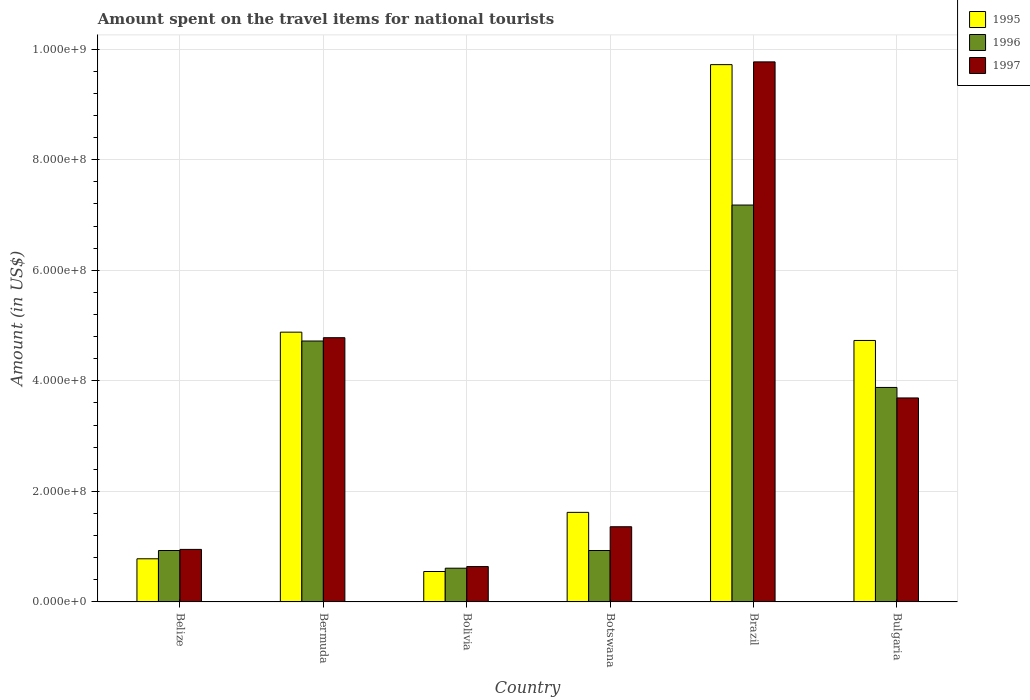How many different coloured bars are there?
Provide a succinct answer. 3. How many groups of bars are there?
Offer a very short reply. 6. How many bars are there on the 2nd tick from the left?
Give a very brief answer. 3. What is the label of the 2nd group of bars from the left?
Your answer should be very brief. Bermuda. In how many cases, is the number of bars for a given country not equal to the number of legend labels?
Offer a very short reply. 0. What is the amount spent on the travel items for national tourists in 1995 in Belize?
Your answer should be very brief. 7.80e+07. Across all countries, what is the maximum amount spent on the travel items for national tourists in 1997?
Make the answer very short. 9.77e+08. Across all countries, what is the minimum amount spent on the travel items for national tourists in 1995?
Keep it short and to the point. 5.50e+07. In which country was the amount spent on the travel items for national tourists in 1995 maximum?
Provide a succinct answer. Brazil. In which country was the amount spent on the travel items for national tourists in 1996 minimum?
Give a very brief answer. Bolivia. What is the total amount spent on the travel items for national tourists in 1995 in the graph?
Ensure brevity in your answer.  2.23e+09. What is the difference between the amount spent on the travel items for national tourists in 1997 in Belize and that in Bermuda?
Offer a very short reply. -3.83e+08. What is the difference between the amount spent on the travel items for national tourists in 1997 in Botswana and the amount spent on the travel items for national tourists in 1995 in Bolivia?
Ensure brevity in your answer.  8.10e+07. What is the average amount spent on the travel items for national tourists in 1997 per country?
Provide a short and direct response. 3.53e+08. What is the difference between the amount spent on the travel items for national tourists of/in 1995 and amount spent on the travel items for national tourists of/in 1996 in Bulgaria?
Your answer should be very brief. 8.50e+07. What is the ratio of the amount spent on the travel items for national tourists in 1995 in Bermuda to that in Botswana?
Provide a short and direct response. 3.01. Is the difference between the amount spent on the travel items for national tourists in 1995 in Brazil and Bulgaria greater than the difference between the amount spent on the travel items for national tourists in 1996 in Brazil and Bulgaria?
Give a very brief answer. Yes. What is the difference between the highest and the second highest amount spent on the travel items for national tourists in 1997?
Offer a very short reply. 6.08e+08. What is the difference between the highest and the lowest amount spent on the travel items for national tourists in 1995?
Make the answer very short. 9.17e+08. In how many countries, is the amount spent on the travel items for national tourists in 1996 greater than the average amount spent on the travel items for national tourists in 1996 taken over all countries?
Ensure brevity in your answer.  3. Is the sum of the amount spent on the travel items for national tourists in 1996 in Belize and Bermuda greater than the maximum amount spent on the travel items for national tourists in 1997 across all countries?
Your answer should be compact. No. What does the 2nd bar from the left in Brazil represents?
Provide a short and direct response. 1996. What does the 1st bar from the right in Bulgaria represents?
Offer a very short reply. 1997. Is it the case that in every country, the sum of the amount spent on the travel items for national tourists in 1996 and amount spent on the travel items for national tourists in 1997 is greater than the amount spent on the travel items for national tourists in 1995?
Make the answer very short. Yes. How many bars are there?
Offer a very short reply. 18. How many countries are there in the graph?
Your answer should be very brief. 6. What is the difference between two consecutive major ticks on the Y-axis?
Keep it short and to the point. 2.00e+08. Are the values on the major ticks of Y-axis written in scientific E-notation?
Offer a terse response. Yes. Does the graph contain any zero values?
Offer a terse response. No. Where does the legend appear in the graph?
Offer a very short reply. Top right. How many legend labels are there?
Your answer should be compact. 3. How are the legend labels stacked?
Provide a short and direct response. Vertical. What is the title of the graph?
Provide a succinct answer. Amount spent on the travel items for national tourists. Does "1993" appear as one of the legend labels in the graph?
Offer a very short reply. No. What is the label or title of the X-axis?
Ensure brevity in your answer.  Country. What is the label or title of the Y-axis?
Make the answer very short. Amount (in US$). What is the Amount (in US$) of 1995 in Belize?
Your answer should be compact. 7.80e+07. What is the Amount (in US$) of 1996 in Belize?
Keep it short and to the point. 9.30e+07. What is the Amount (in US$) of 1997 in Belize?
Provide a succinct answer. 9.50e+07. What is the Amount (in US$) in 1995 in Bermuda?
Your answer should be very brief. 4.88e+08. What is the Amount (in US$) of 1996 in Bermuda?
Your answer should be compact. 4.72e+08. What is the Amount (in US$) in 1997 in Bermuda?
Give a very brief answer. 4.78e+08. What is the Amount (in US$) of 1995 in Bolivia?
Your answer should be compact. 5.50e+07. What is the Amount (in US$) in 1996 in Bolivia?
Offer a very short reply. 6.10e+07. What is the Amount (in US$) in 1997 in Bolivia?
Provide a succinct answer. 6.40e+07. What is the Amount (in US$) of 1995 in Botswana?
Provide a short and direct response. 1.62e+08. What is the Amount (in US$) of 1996 in Botswana?
Provide a succinct answer. 9.30e+07. What is the Amount (in US$) in 1997 in Botswana?
Your answer should be very brief. 1.36e+08. What is the Amount (in US$) of 1995 in Brazil?
Ensure brevity in your answer.  9.72e+08. What is the Amount (in US$) in 1996 in Brazil?
Ensure brevity in your answer.  7.18e+08. What is the Amount (in US$) in 1997 in Brazil?
Offer a very short reply. 9.77e+08. What is the Amount (in US$) in 1995 in Bulgaria?
Ensure brevity in your answer.  4.73e+08. What is the Amount (in US$) in 1996 in Bulgaria?
Your answer should be compact. 3.88e+08. What is the Amount (in US$) of 1997 in Bulgaria?
Offer a terse response. 3.69e+08. Across all countries, what is the maximum Amount (in US$) in 1995?
Ensure brevity in your answer.  9.72e+08. Across all countries, what is the maximum Amount (in US$) of 1996?
Your answer should be very brief. 7.18e+08. Across all countries, what is the maximum Amount (in US$) in 1997?
Ensure brevity in your answer.  9.77e+08. Across all countries, what is the minimum Amount (in US$) of 1995?
Your answer should be compact. 5.50e+07. Across all countries, what is the minimum Amount (in US$) in 1996?
Offer a very short reply. 6.10e+07. Across all countries, what is the minimum Amount (in US$) of 1997?
Make the answer very short. 6.40e+07. What is the total Amount (in US$) of 1995 in the graph?
Your response must be concise. 2.23e+09. What is the total Amount (in US$) in 1996 in the graph?
Your answer should be very brief. 1.82e+09. What is the total Amount (in US$) in 1997 in the graph?
Keep it short and to the point. 2.12e+09. What is the difference between the Amount (in US$) of 1995 in Belize and that in Bermuda?
Keep it short and to the point. -4.10e+08. What is the difference between the Amount (in US$) of 1996 in Belize and that in Bermuda?
Offer a very short reply. -3.79e+08. What is the difference between the Amount (in US$) in 1997 in Belize and that in Bermuda?
Offer a terse response. -3.83e+08. What is the difference between the Amount (in US$) of 1995 in Belize and that in Bolivia?
Offer a very short reply. 2.30e+07. What is the difference between the Amount (in US$) of 1996 in Belize and that in Bolivia?
Provide a succinct answer. 3.20e+07. What is the difference between the Amount (in US$) of 1997 in Belize and that in Bolivia?
Your response must be concise. 3.10e+07. What is the difference between the Amount (in US$) of 1995 in Belize and that in Botswana?
Your answer should be very brief. -8.40e+07. What is the difference between the Amount (in US$) in 1997 in Belize and that in Botswana?
Offer a very short reply. -4.10e+07. What is the difference between the Amount (in US$) of 1995 in Belize and that in Brazil?
Ensure brevity in your answer.  -8.94e+08. What is the difference between the Amount (in US$) in 1996 in Belize and that in Brazil?
Your response must be concise. -6.25e+08. What is the difference between the Amount (in US$) of 1997 in Belize and that in Brazil?
Give a very brief answer. -8.82e+08. What is the difference between the Amount (in US$) in 1995 in Belize and that in Bulgaria?
Keep it short and to the point. -3.95e+08. What is the difference between the Amount (in US$) in 1996 in Belize and that in Bulgaria?
Keep it short and to the point. -2.95e+08. What is the difference between the Amount (in US$) in 1997 in Belize and that in Bulgaria?
Provide a succinct answer. -2.74e+08. What is the difference between the Amount (in US$) of 1995 in Bermuda and that in Bolivia?
Give a very brief answer. 4.33e+08. What is the difference between the Amount (in US$) of 1996 in Bermuda and that in Bolivia?
Your answer should be compact. 4.11e+08. What is the difference between the Amount (in US$) in 1997 in Bermuda and that in Bolivia?
Keep it short and to the point. 4.14e+08. What is the difference between the Amount (in US$) of 1995 in Bermuda and that in Botswana?
Provide a short and direct response. 3.26e+08. What is the difference between the Amount (in US$) of 1996 in Bermuda and that in Botswana?
Make the answer very short. 3.79e+08. What is the difference between the Amount (in US$) in 1997 in Bermuda and that in Botswana?
Give a very brief answer. 3.42e+08. What is the difference between the Amount (in US$) of 1995 in Bermuda and that in Brazil?
Your answer should be compact. -4.84e+08. What is the difference between the Amount (in US$) in 1996 in Bermuda and that in Brazil?
Offer a terse response. -2.46e+08. What is the difference between the Amount (in US$) of 1997 in Bermuda and that in Brazil?
Your answer should be very brief. -4.99e+08. What is the difference between the Amount (in US$) in 1995 in Bermuda and that in Bulgaria?
Ensure brevity in your answer.  1.50e+07. What is the difference between the Amount (in US$) of 1996 in Bermuda and that in Bulgaria?
Provide a succinct answer. 8.40e+07. What is the difference between the Amount (in US$) of 1997 in Bermuda and that in Bulgaria?
Keep it short and to the point. 1.09e+08. What is the difference between the Amount (in US$) in 1995 in Bolivia and that in Botswana?
Your response must be concise. -1.07e+08. What is the difference between the Amount (in US$) in 1996 in Bolivia and that in Botswana?
Your response must be concise. -3.20e+07. What is the difference between the Amount (in US$) in 1997 in Bolivia and that in Botswana?
Give a very brief answer. -7.20e+07. What is the difference between the Amount (in US$) of 1995 in Bolivia and that in Brazil?
Ensure brevity in your answer.  -9.17e+08. What is the difference between the Amount (in US$) of 1996 in Bolivia and that in Brazil?
Ensure brevity in your answer.  -6.57e+08. What is the difference between the Amount (in US$) of 1997 in Bolivia and that in Brazil?
Make the answer very short. -9.13e+08. What is the difference between the Amount (in US$) in 1995 in Bolivia and that in Bulgaria?
Provide a succinct answer. -4.18e+08. What is the difference between the Amount (in US$) in 1996 in Bolivia and that in Bulgaria?
Keep it short and to the point. -3.27e+08. What is the difference between the Amount (in US$) of 1997 in Bolivia and that in Bulgaria?
Make the answer very short. -3.05e+08. What is the difference between the Amount (in US$) in 1995 in Botswana and that in Brazil?
Make the answer very short. -8.10e+08. What is the difference between the Amount (in US$) in 1996 in Botswana and that in Brazil?
Provide a short and direct response. -6.25e+08. What is the difference between the Amount (in US$) of 1997 in Botswana and that in Brazil?
Provide a succinct answer. -8.41e+08. What is the difference between the Amount (in US$) of 1995 in Botswana and that in Bulgaria?
Provide a short and direct response. -3.11e+08. What is the difference between the Amount (in US$) of 1996 in Botswana and that in Bulgaria?
Give a very brief answer. -2.95e+08. What is the difference between the Amount (in US$) in 1997 in Botswana and that in Bulgaria?
Your response must be concise. -2.33e+08. What is the difference between the Amount (in US$) in 1995 in Brazil and that in Bulgaria?
Your answer should be very brief. 4.99e+08. What is the difference between the Amount (in US$) in 1996 in Brazil and that in Bulgaria?
Provide a short and direct response. 3.30e+08. What is the difference between the Amount (in US$) of 1997 in Brazil and that in Bulgaria?
Offer a terse response. 6.08e+08. What is the difference between the Amount (in US$) of 1995 in Belize and the Amount (in US$) of 1996 in Bermuda?
Give a very brief answer. -3.94e+08. What is the difference between the Amount (in US$) of 1995 in Belize and the Amount (in US$) of 1997 in Bermuda?
Offer a terse response. -4.00e+08. What is the difference between the Amount (in US$) in 1996 in Belize and the Amount (in US$) in 1997 in Bermuda?
Offer a terse response. -3.85e+08. What is the difference between the Amount (in US$) in 1995 in Belize and the Amount (in US$) in 1996 in Bolivia?
Give a very brief answer. 1.70e+07. What is the difference between the Amount (in US$) in 1995 in Belize and the Amount (in US$) in 1997 in Bolivia?
Your response must be concise. 1.40e+07. What is the difference between the Amount (in US$) of 1996 in Belize and the Amount (in US$) of 1997 in Bolivia?
Offer a very short reply. 2.90e+07. What is the difference between the Amount (in US$) in 1995 in Belize and the Amount (in US$) in 1996 in Botswana?
Ensure brevity in your answer.  -1.50e+07. What is the difference between the Amount (in US$) in 1995 in Belize and the Amount (in US$) in 1997 in Botswana?
Your response must be concise. -5.80e+07. What is the difference between the Amount (in US$) in 1996 in Belize and the Amount (in US$) in 1997 in Botswana?
Offer a very short reply. -4.30e+07. What is the difference between the Amount (in US$) of 1995 in Belize and the Amount (in US$) of 1996 in Brazil?
Provide a succinct answer. -6.40e+08. What is the difference between the Amount (in US$) of 1995 in Belize and the Amount (in US$) of 1997 in Brazil?
Your response must be concise. -8.99e+08. What is the difference between the Amount (in US$) in 1996 in Belize and the Amount (in US$) in 1997 in Brazil?
Provide a short and direct response. -8.84e+08. What is the difference between the Amount (in US$) of 1995 in Belize and the Amount (in US$) of 1996 in Bulgaria?
Provide a short and direct response. -3.10e+08. What is the difference between the Amount (in US$) of 1995 in Belize and the Amount (in US$) of 1997 in Bulgaria?
Your answer should be compact. -2.91e+08. What is the difference between the Amount (in US$) of 1996 in Belize and the Amount (in US$) of 1997 in Bulgaria?
Ensure brevity in your answer.  -2.76e+08. What is the difference between the Amount (in US$) of 1995 in Bermuda and the Amount (in US$) of 1996 in Bolivia?
Your answer should be compact. 4.27e+08. What is the difference between the Amount (in US$) in 1995 in Bermuda and the Amount (in US$) in 1997 in Bolivia?
Provide a short and direct response. 4.24e+08. What is the difference between the Amount (in US$) in 1996 in Bermuda and the Amount (in US$) in 1997 in Bolivia?
Your answer should be very brief. 4.08e+08. What is the difference between the Amount (in US$) of 1995 in Bermuda and the Amount (in US$) of 1996 in Botswana?
Make the answer very short. 3.95e+08. What is the difference between the Amount (in US$) in 1995 in Bermuda and the Amount (in US$) in 1997 in Botswana?
Ensure brevity in your answer.  3.52e+08. What is the difference between the Amount (in US$) in 1996 in Bermuda and the Amount (in US$) in 1997 in Botswana?
Give a very brief answer. 3.36e+08. What is the difference between the Amount (in US$) in 1995 in Bermuda and the Amount (in US$) in 1996 in Brazil?
Make the answer very short. -2.30e+08. What is the difference between the Amount (in US$) of 1995 in Bermuda and the Amount (in US$) of 1997 in Brazil?
Your answer should be compact. -4.89e+08. What is the difference between the Amount (in US$) in 1996 in Bermuda and the Amount (in US$) in 1997 in Brazil?
Make the answer very short. -5.05e+08. What is the difference between the Amount (in US$) of 1995 in Bermuda and the Amount (in US$) of 1997 in Bulgaria?
Keep it short and to the point. 1.19e+08. What is the difference between the Amount (in US$) in 1996 in Bermuda and the Amount (in US$) in 1997 in Bulgaria?
Offer a very short reply. 1.03e+08. What is the difference between the Amount (in US$) in 1995 in Bolivia and the Amount (in US$) in 1996 in Botswana?
Provide a succinct answer. -3.80e+07. What is the difference between the Amount (in US$) of 1995 in Bolivia and the Amount (in US$) of 1997 in Botswana?
Provide a succinct answer. -8.10e+07. What is the difference between the Amount (in US$) in 1996 in Bolivia and the Amount (in US$) in 1997 in Botswana?
Provide a short and direct response. -7.50e+07. What is the difference between the Amount (in US$) of 1995 in Bolivia and the Amount (in US$) of 1996 in Brazil?
Offer a very short reply. -6.63e+08. What is the difference between the Amount (in US$) in 1995 in Bolivia and the Amount (in US$) in 1997 in Brazil?
Keep it short and to the point. -9.22e+08. What is the difference between the Amount (in US$) in 1996 in Bolivia and the Amount (in US$) in 1997 in Brazil?
Your answer should be very brief. -9.16e+08. What is the difference between the Amount (in US$) of 1995 in Bolivia and the Amount (in US$) of 1996 in Bulgaria?
Make the answer very short. -3.33e+08. What is the difference between the Amount (in US$) of 1995 in Bolivia and the Amount (in US$) of 1997 in Bulgaria?
Provide a succinct answer. -3.14e+08. What is the difference between the Amount (in US$) of 1996 in Bolivia and the Amount (in US$) of 1997 in Bulgaria?
Provide a succinct answer. -3.08e+08. What is the difference between the Amount (in US$) of 1995 in Botswana and the Amount (in US$) of 1996 in Brazil?
Your answer should be very brief. -5.56e+08. What is the difference between the Amount (in US$) of 1995 in Botswana and the Amount (in US$) of 1997 in Brazil?
Provide a short and direct response. -8.15e+08. What is the difference between the Amount (in US$) in 1996 in Botswana and the Amount (in US$) in 1997 in Brazil?
Keep it short and to the point. -8.84e+08. What is the difference between the Amount (in US$) in 1995 in Botswana and the Amount (in US$) in 1996 in Bulgaria?
Your answer should be compact. -2.26e+08. What is the difference between the Amount (in US$) of 1995 in Botswana and the Amount (in US$) of 1997 in Bulgaria?
Make the answer very short. -2.07e+08. What is the difference between the Amount (in US$) of 1996 in Botswana and the Amount (in US$) of 1997 in Bulgaria?
Give a very brief answer. -2.76e+08. What is the difference between the Amount (in US$) in 1995 in Brazil and the Amount (in US$) in 1996 in Bulgaria?
Ensure brevity in your answer.  5.84e+08. What is the difference between the Amount (in US$) in 1995 in Brazil and the Amount (in US$) in 1997 in Bulgaria?
Your answer should be very brief. 6.03e+08. What is the difference between the Amount (in US$) in 1996 in Brazil and the Amount (in US$) in 1997 in Bulgaria?
Ensure brevity in your answer.  3.49e+08. What is the average Amount (in US$) in 1995 per country?
Give a very brief answer. 3.71e+08. What is the average Amount (in US$) of 1996 per country?
Keep it short and to the point. 3.04e+08. What is the average Amount (in US$) of 1997 per country?
Give a very brief answer. 3.53e+08. What is the difference between the Amount (in US$) of 1995 and Amount (in US$) of 1996 in Belize?
Offer a terse response. -1.50e+07. What is the difference between the Amount (in US$) in 1995 and Amount (in US$) in 1997 in Belize?
Provide a short and direct response. -1.70e+07. What is the difference between the Amount (in US$) of 1996 and Amount (in US$) of 1997 in Belize?
Make the answer very short. -2.00e+06. What is the difference between the Amount (in US$) in 1995 and Amount (in US$) in 1996 in Bermuda?
Give a very brief answer. 1.60e+07. What is the difference between the Amount (in US$) in 1995 and Amount (in US$) in 1997 in Bermuda?
Ensure brevity in your answer.  1.00e+07. What is the difference between the Amount (in US$) in 1996 and Amount (in US$) in 1997 in Bermuda?
Offer a terse response. -6.00e+06. What is the difference between the Amount (in US$) of 1995 and Amount (in US$) of 1996 in Bolivia?
Ensure brevity in your answer.  -6.00e+06. What is the difference between the Amount (in US$) of 1995 and Amount (in US$) of 1997 in Bolivia?
Keep it short and to the point. -9.00e+06. What is the difference between the Amount (in US$) of 1996 and Amount (in US$) of 1997 in Bolivia?
Provide a short and direct response. -3.00e+06. What is the difference between the Amount (in US$) in 1995 and Amount (in US$) in 1996 in Botswana?
Ensure brevity in your answer.  6.90e+07. What is the difference between the Amount (in US$) of 1995 and Amount (in US$) of 1997 in Botswana?
Offer a very short reply. 2.60e+07. What is the difference between the Amount (in US$) in 1996 and Amount (in US$) in 1997 in Botswana?
Offer a very short reply. -4.30e+07. What is the difference between the Amount (in US$) of 1995 and Amount (in US$) of 1996 in Brazil?
Your answer should be compact. 2.54e+08. What is the difference between the Amount (in US$) of 1995 and Amount (in US$) of 1997 in Brazil?
Provide a short and direct response. -5.00e+06. What is the difference between the Amount (in US$) in 1996 and Amount (in US$) in 1997 in Brazil?
Make the answer very short. -2.59e+08. What is the difference between the Amount (in US$) of 1995 and Amount (in US$) of 1996 in Bulgaria?
Your answer should be compact. 8.50e+07. What is the difference between the Amount (in US$) of 1995 and Amount (in US$) of 1997 in Bulgaria?
Offer a very short reply. 1.04e+08. What is the difference between the Amount (in US$) of 1996 and Amount (in US$) of 1997 in Bulgaria?
Keep it short and to the point. 1.90e+07. What is the ratio of the Amount (in US$) in 1995 in Belize to that in Bermuda?
Keep it short and to the point. 0.16. What is the ratio of the Amount (in US$) in 1996 in Belize to that in Bermuda?
Keep it short and to the point. 0.2. What is the ratio of the Amount (in US$) in 1997 in Belize to that in Bermuda?
Offer a terse response. 0.2. What is the ratio of the Amount (in US$) in 1995 in Belize to that in Bolivia?
Ensure brevity in your answer.  1.42. What is the ratio of the Amount (in US$) of 1996 in Belize to that in Bolivia?
Provide a short and direct response. 1.52. What is the ratio of the Amount (in US$) of 1997 in Belize to that in Bolivia?
Make the answer very short. 1.48. What is the ratio of the Amount (in US$) in 1995 in Belize to that in Botswana?
Your answer should be compact. 0.48. What is the ratio of the Amount (in US$) of 1997 in Belize to that in Botswana?
Keep it short and to the point. 0.7. What is the ratio of the Amount (in US$) of 1995 in Belize to that in Brazil?
Your answer should be compact. 0.08. What is the ratio of the Amount (in US$) of 1996 in Belize to that in Brazil?
Your response must be concise. 0.13. What is the ratio of the Amount (in US$) of 1997 in Belize to that in Brazil?
Provide a short and direct response. 0.1. What is the ratio of the Amount (in US$) in 1995 in Belize to that in Bulgaria?
Provide a short and direct response. 0.16. What is the ratio of the Amount (in US$) in 1996 in Belize to that in Bulgaria?
Provide a succinct answer. 0.24. What is the ratio of the Amount (in US$) of 1997 in Belize to that in Bulgaria?
Offer a terse response. 0.26. What is the ratio of the Amount (in US$) in 1995 in Bermuda to that in Bolivia?
Keep it short and to the point. 8.87. What is the ratio of the Amount (in US$) in 1996 in Bermuda to that in Bolivia?
Make the answer very short. 7.74. What is the ratio of the Amount (in US$) in 1997 in Bermuda to that in Bolivia?
Offer a terse response. 7.47. What is the ratio of the Amount (in US$) in 1995 in Bermuda to that in Botswana?
Your response must be concise. 3.01. What is the ratio of the Amount (in US$) of 1996 in Bermuda to that in Botswana?
Ensure brevity in your answer.  5.08. What is the ratio of the Amount (in US$) of 1997 in Bermuda to that in Botswana?
Provide a short and direct response. 3.51. What is the ratio of the Amount (in US$) in 1995 in Bermuda to that in Brazil?
Provide a succinct answer. 0.5. What is the ratio of the Amount (in US$) of 1996 in Bermuda to that in Brazil?
Offer a very short reply. 0.66. What is the ratio of the Amount (in US$) of 1997 in Bermuda to that in Brazil?
Ensure brevity in your answer.  0.49. What is the ratio of the Amount (in US$) of 1995 in Bermuda to that in Bulgaria?
Offer a very short reply. 1.03. What is the ratio of the Amount (in US$) of 1996 in Bermuda to that in Bulgaria?
Keep it short and to the point. 1.22. What is the ratio of the Amount (in US$) of 1997 in Bermuda to that in Bulgaria?
Offer a very short reply. 1.3. What is the ratio of the Amount (in US$) of 1995 in Bolivia to that in Botswana?
Offer a terse response. 0.34. What is the ratio of the Amount (in US$) in 1996 in Bolivia to that in Botswana?
Ensure brevity in your answer.  0.66. What is the ratio of the Amount (in US$) in 1997 in Bolivia to that in Botswana?
Give a very brief answer. 0.47. What is the ratio of the Amount (in US$) in 1995 in Bolivia to that in Brazil?
Make the answer very short. 0.06. What is the ratio of the Amount (in US$) in 1996 in Bolivia to that in Brazil?
Your response must be concise. 0.09. What is the ratio of the Amount (in US$) in 1997 in Bolivia to that in Brazil?
Provide a succinct answer. 0.07. What is the ratio of the Amount (in US$) of 1995 in Bolivia to that in Bulgaria?
Make the answer very short. 0.12. What is the ratio of the Amount (in US$) of 1996 in Bolivia to that in Bulgaria?
Your response must be concise. 0.16. What is the ratio of the Amount (in US$) in 1997 in Bolivia to that in Bulgaria?
Offer a very short reply. 0.17. What is the ratio of the Amount (in US$) of 1996 in Botswana to that in Brazil?
Make the answer very short. 0.13. What is the ratio of the Amount (in US$) in 1997 in Botswana to that in Brazil?
Ensure brevity in your answer.  0.14. What is the ratio of the Amount (in US$) of 1995 in Botswana to that in Bulgaria?
Keep it short and to the point. 0.34. What is the ratio of the Amount (in US$) of 1996 in Botswana to that in Bulgaria?
Offer a very short reply. 0.24. What is the ratio of the Amount (in US$) of 1997 in Botswana to that in Bulgaria?
Make the answer very short. 0.37. What is the ratio of the Amount (in US$) of 1995 in Brazil to that in Bulgaria?
Your answer should be compact. 2.06. What is the ratio of the Amount (in US$) in 1996 in Brazil to that in Bulgaria?
Your answer should be very brief. 1.85. What is the ratio of the Amount (in US$) in 1997 in Brazil to that in Bulgaria?
Offer a terse response. 2.65. What is the difference between the highest and the second highest Amount (in US$) of 1995?
Provide a succinct answer. 4.84e+08. What is the difference between the highest and the second highest Amount (in US$) in 1996?
Keep it short and to the point. 2.46e+08. What is the difference between the highest and the second highest Amount (in US$) in 1997?
Give a very brief answer. 4.99e+08. What is the difference between the highest and the lowest Amount (in US$) of 1995?
Make the answer very short. 9.17e+08. What is the difference between the highest and the lowest Amount (in US$) of 1996?
Offer a terse response. 6.57e+08. What is the difference between the highest and the lowest Amount (in US$) of 1997?
Your answer should be very brief. 9.13e+08. 